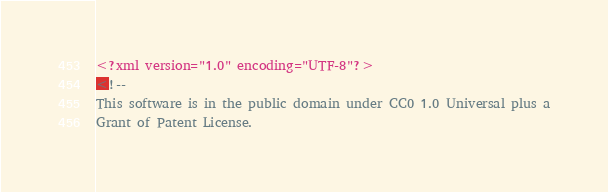<code> <loc_0><loc_0><loc_500><loc_500><_XML_><?xml version="1.0" encoding="UTF-8"?>
<!--
This software is in the public domain under CC0 1.0 Universal plus a
Grant of Patent License.
</code> 